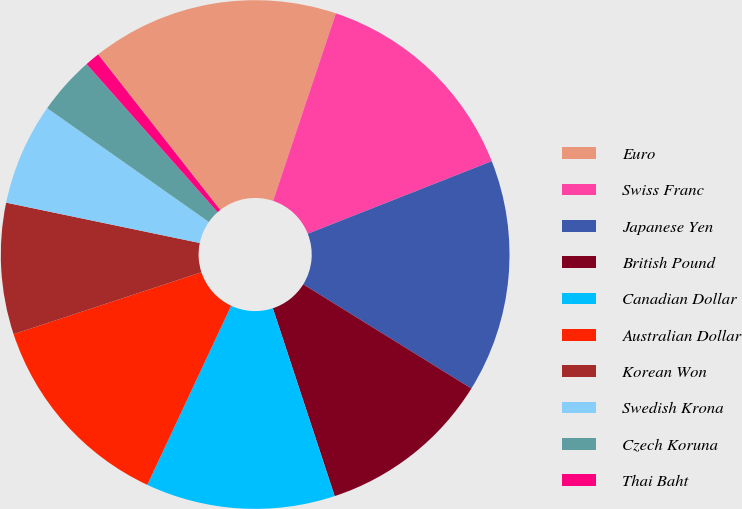<chart> <loc_0><loc_0><loc_500><loc_500><pie_chart><fcel>Euro<fcel>Swiss Franc<fcel>Japanese Yen<fcel>British Pound<fcel>Canadian Dollar<fcel>Australian Dollar<fcel>Korean Won<fcel>Swedish Krona<fcel>Czech Koruna<fcel>Thai Baht<nl><fcel>15.73%<fcel>13.88%<fcel>14.81%<fcel>11.11%<fcel>12.03%<fcel>12.96%<fcel>8.34%<fcel>6.49%<fcel>3.71%<fcel>0.94%<nl></chart> 